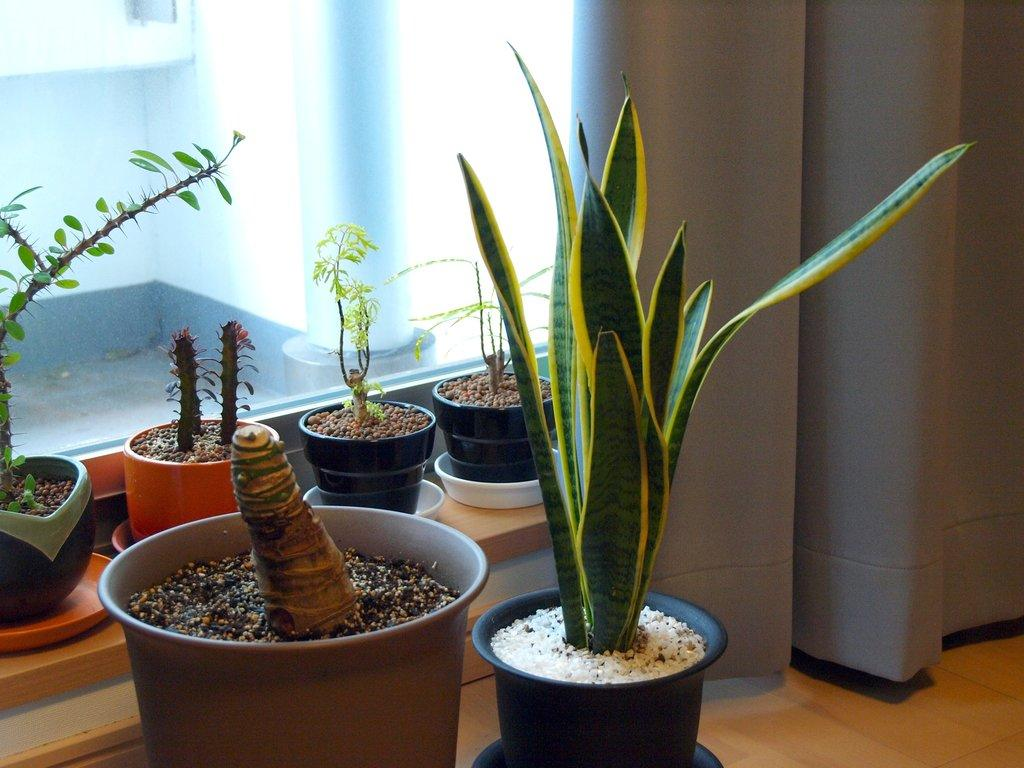What is the main piece of furniture in the image? There is a table in the image. What is placed on the table? There is a flower pot and a plate on the table. What is inside the flower pot? There are stones in the flower pot. What type of window treatment is present in the image? There are curtains in the image. What architectural feature is visible in the image? There is a window and a pillar in the image. What type of muscle can be seen flexing in the image? There is no muscle visible in the image. How many chickens are present in the image? There are no chickens present in the image. 